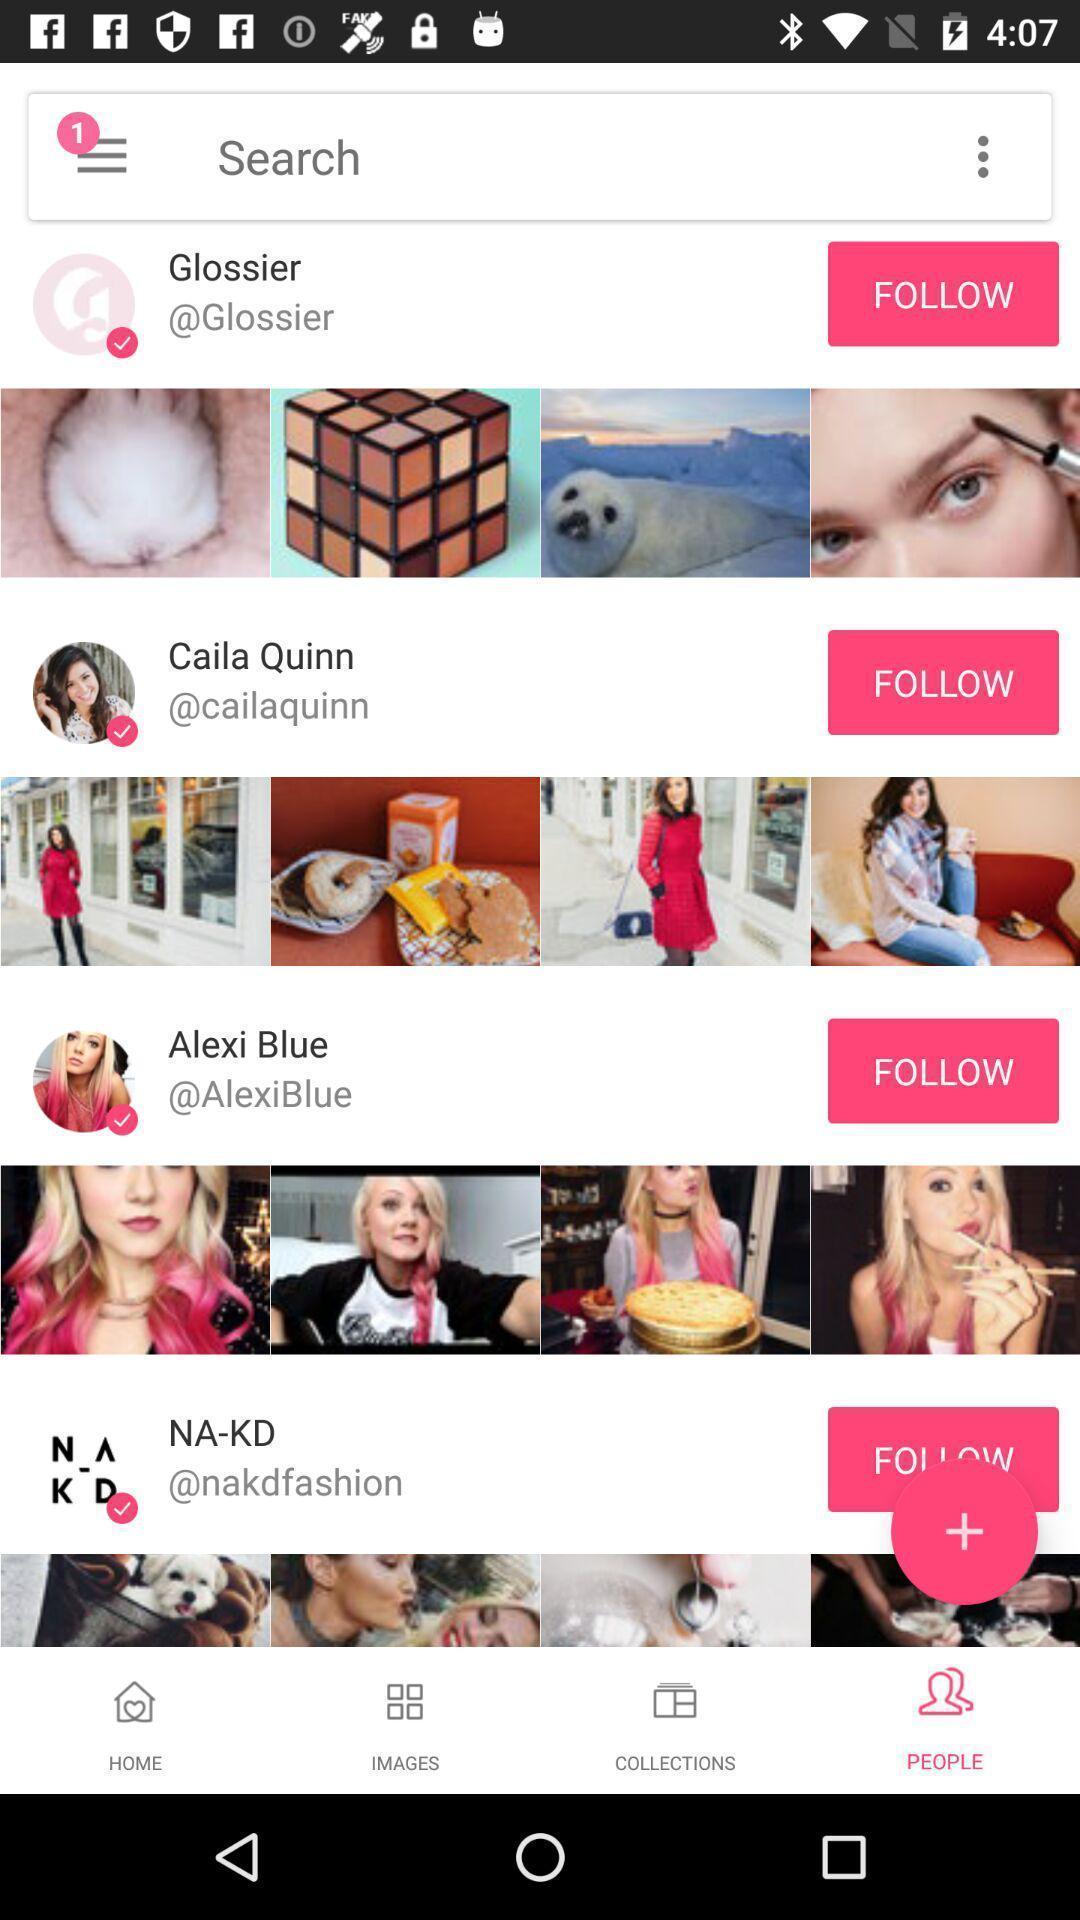Provide a description of this screenshot. Search page of a social media app. 